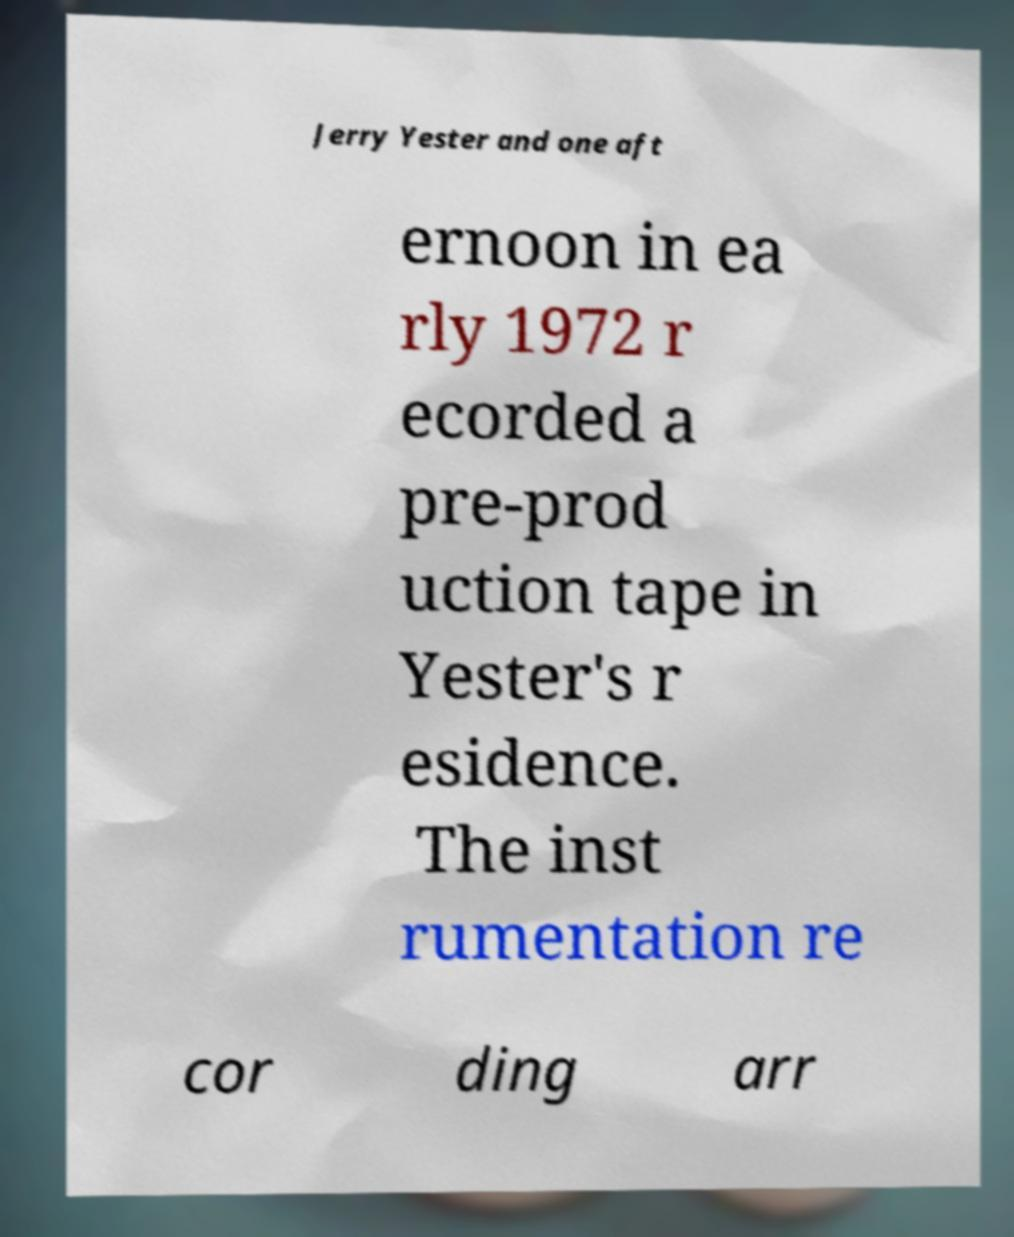Please identify and transcribe the text found in this image. Jerry Yester and one aft ernoon in ea rly 1972 r ecorded a pre-prod uction tape in Yester's r esidence. The inst rumentation re cor ding arr 